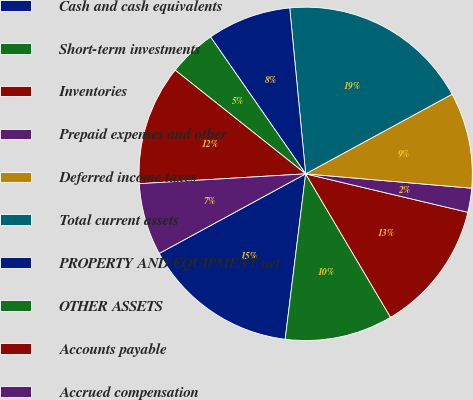Convert chart to OTSL. <chart><loc_0><loc_0><loc_500><loc_500><pie_chart><fcel>Cash and cash equivalents<fcel>Short-term investments<fcel>Inventories<fcel>Prepaid expenses and other<fcel>Deferred income taxes<fcel>Total current assets<fcel>PROPERTY AND EQUIPMENT net<fcel>OTHER ASSETS<fcel>Accounts payable<fcel>Accrued compensation<nl><fcel>15.12%<fcel>10.47%<fcel>12.79%<fcel>2.33%<fcel>9.3%<fcel>18.6%<fcel>8.14%<fcel>4.65%<fcel>11.63%<fcel>6.98%<nl></chart> 